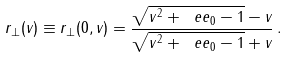<formula> <loc_0><loc_0><loc_500><loc_500>r _ { \bot } ( v ) \equiv r _ { \bot } ( 0 , v ) = \frac { \sqrt { v ^ { 2 } + { \ e e } _ { 0 } - 1 } - v } { \sqrt { v ^ { 2 } + { \ e e } _ { 0 } - 1 } + v } \, .</formula> 